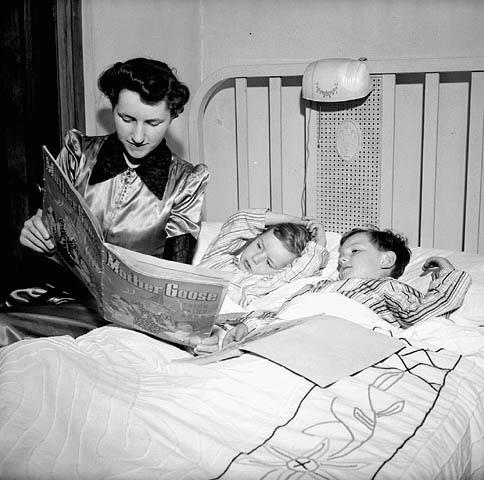Why is this book appropriate for her to read? nursery rhyme 